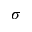Convert formula to latex. <formula><loc_0><loc_0><loc_500><loc_500>\sigma</formula> 